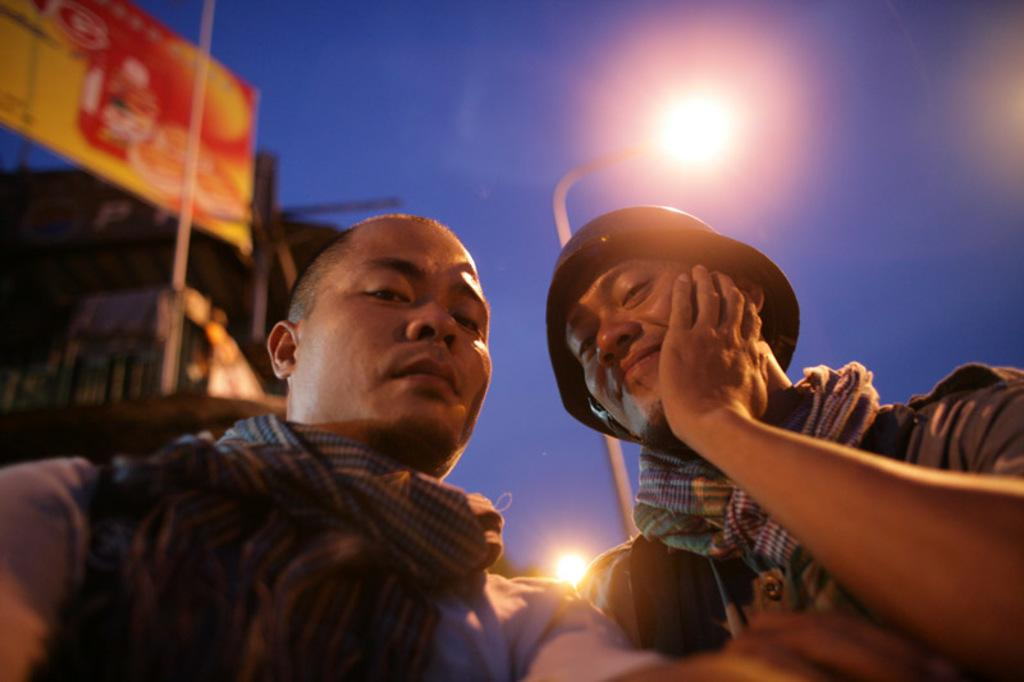Who is present in the image? There are men in the image. What are the men wearing around their necks? The men are wearing scarfs. What type of headwear do the men have? The men have caps on their heads. What type of lighting is present in the image? There are pole lights in the image. What type of structure is visible in the image? There is a building in the image. What type of signage is present in the image? There is an advertisement hoarding in the image. What is the color of the sky in the image? The sky is blue. What type of question is being asked by the man in the image? There is no man asking a question in the image. What type of fang can be seen in the image? There are no fangs present in the image. 